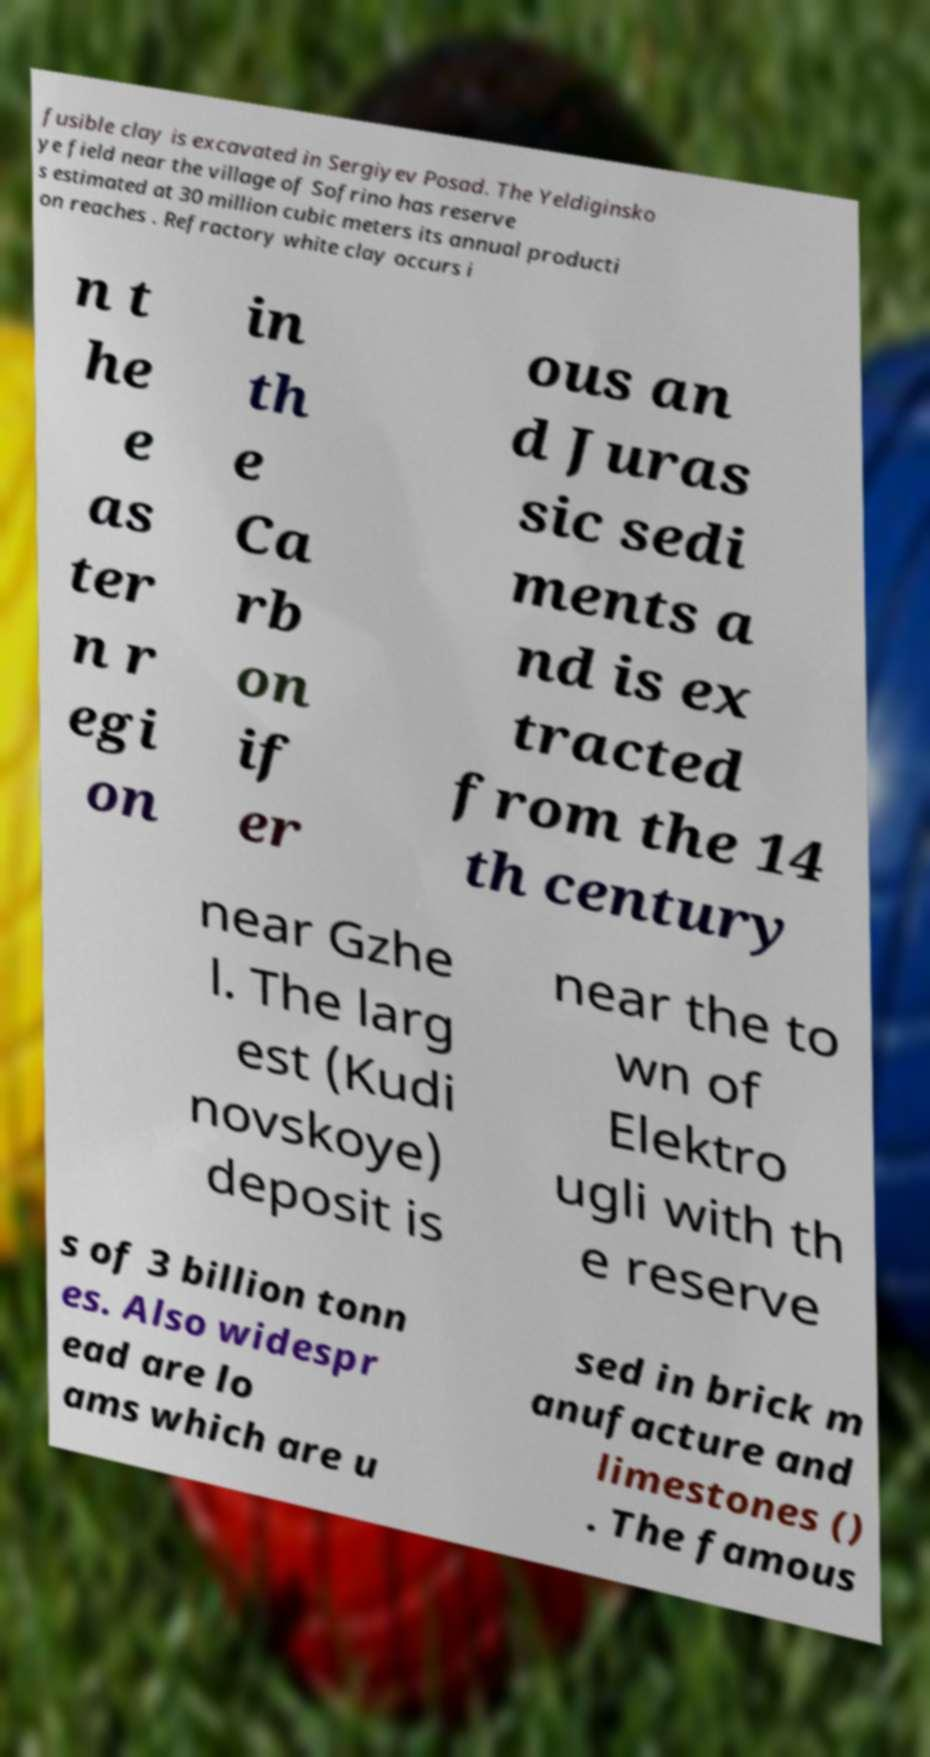Please read and relay the text visible in this image. What does it say? fusible clay is excavated in Sergiyev Posad. The Yeldiginsko ye field near the village of Sofrino has reserve s estimated at 30 million cubic meters its annual producti on reaches . Refractory white clay occurs i n t he e as ter n r egi on in th e Ca rb on if er ous an d Juras sic sedi ments a nd is ex tracted from the 14 th century near Gzhe l. The larg est (Kudi novskoye) deposit is near the to wn of Elektro ugli with th e reserve s of 3 billion tonn es. Also widespr ead are lo ams which are u sed in brick m anufacture and limestones () . The famous 